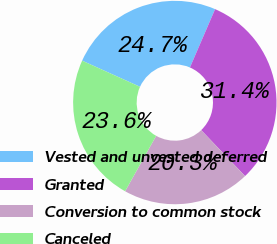Convert chart to OTSL. <chart><loc_0><loc_0><loc_500><loc_500><pie_chart><fcel>Vested and unvested deferred<fcel>Granted<fcel>Conversion to common stock<fcel>Canceled<nl><fcel>24.73%<fcel>31.38%<fcel>20.26%<fcel>23.62%<nl></chart> 